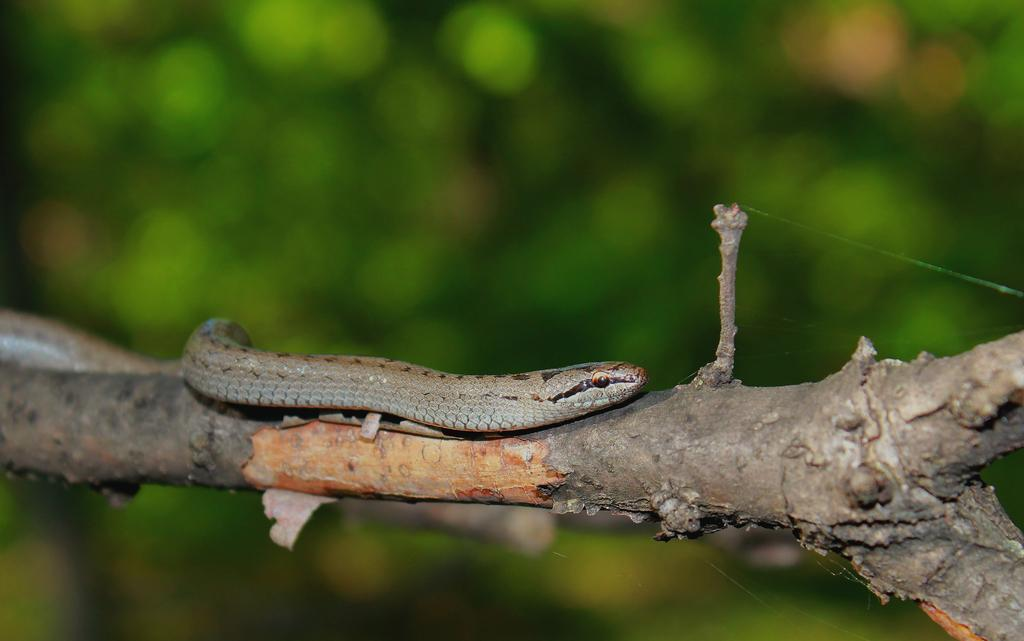What animal is present in the image? There is a snake in the image. Where is the snake located? The snake is on a branch. What color is the background of the image? The background of the image is green. How many chairs can be seen in the image? There are no chairs present in the image; it features a snake on a branch with a green background. 